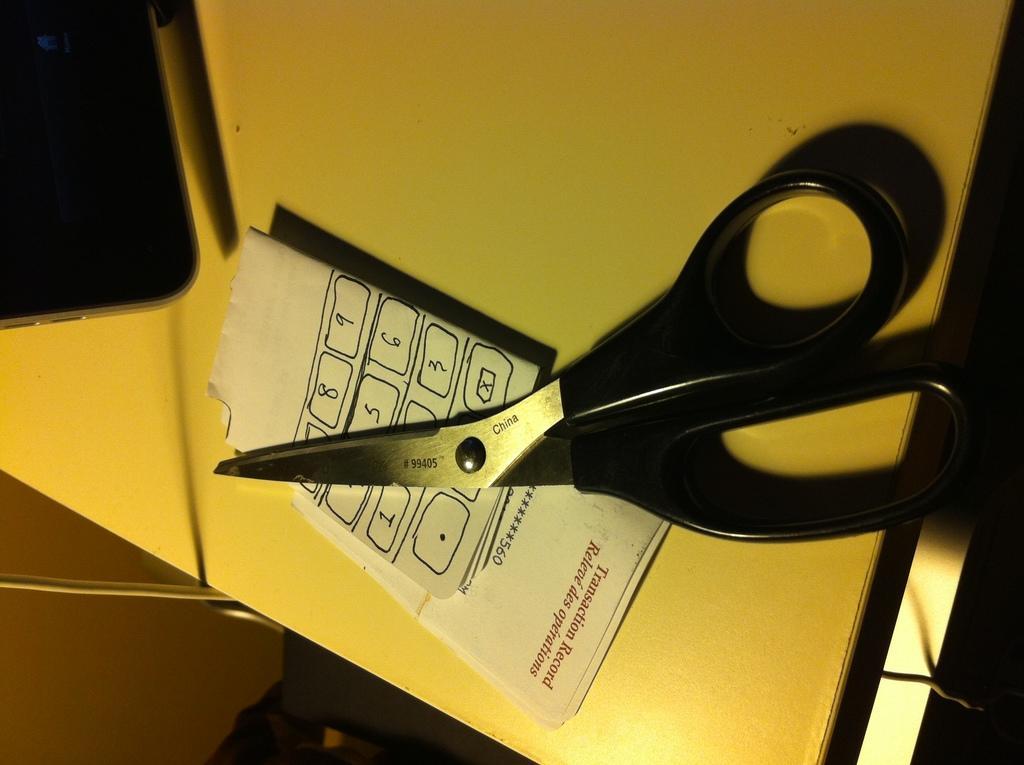Can you describe this image briefly? This picture shows scissors and a paper on the table. 